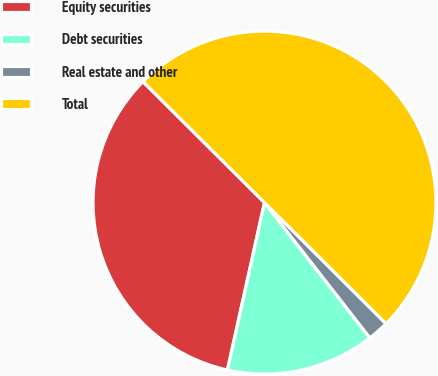<chart> <loc_0><loc_0><loc_500><loc_500><pie_chart><fcel>Equity securities<fcel>Debt securities<fcel>Real estate and other<fcel>Total<nl><fcel>34.0%<fcel>14.0%<fcel>2.0%<fcel>50.0%<nl></chart> 